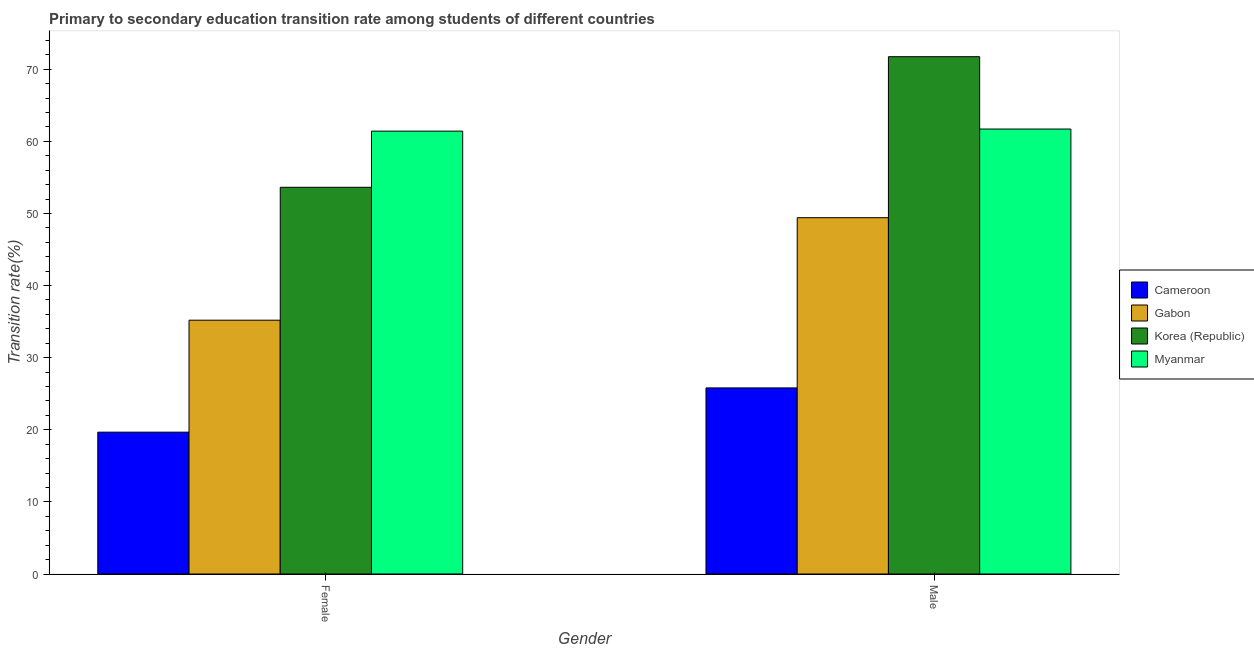How many different coloured bars are there?
Your answer should be very brief. 4. How many bars are there on the 2nd tick from the left?
Keep it short and to the point. 4. What is the label of the 2nd group of bars from the left?
Give a very brief answer. Male. What is the transition rate among male students in Korea (Republic)?
Give a very brief answer. 71.74. Across all countries, what is the maximum transition rate among male students?
Your answer should be very brief. 71.74. Across all countries, what is the minimum transition rate among female students?
Provide a succinct answer. 19.67. In which country was the transition rate among female students maximum?
Keep it short and to the point. Myanmar. In which country was the transition rate among male students minimum?
Make the answer very short. Cameroon. What is the total transition rate among female students in the graph?
Make the answer very short. 169.92. What is the difference between the transition rate among female students in Gabon and that in Myanmar?
Your response must be concise. -26.22. What is the difference between the transition rate among female students in Cameroon and the transition rate among male students in Myanmar?
Your answer should be very brief. -42.04. What is the average transition rate among female students per country?
Offer a terse response. 42.48. What is the difference between the transition rate among male students and transition rate among female students in Korea (Republic)?
Ensure brevity in your answer.  18.11. What is the ratio of the transition rate among female students in Myanmar to that in Cameroon?
Your answer should be compact. 3.12. What does the 2nd bar from the left in Male represents?
Provide a short and direct response. Gabon. What does the 3rd bar from the right in Male represents?
Make the answer very short. Gabon. Are all the bars in the graph horizontal?
Ensure brevity in your answer.  No. How many countries are there in the graph?
Your response must be concise. 4. What is the difference between two consecutive major ticks on the Y-axis?
Give a very brief answer. 10. Are the values on the major ticks of Y-axis written in scientific E-notation?
Make the answer very short. No. Does the graph contain any zero values?
Make the answer very short. No. Does the graph contain grids?
Offer a very short reply. No. How many legend labels are there?
Offer a very short reply. 4. How are the legend labels stacked?
Offer a very short reply. Vertical. What is the title of the graph?
Provide a short and direct response. Primary to secondary education transition rate among students of different countries. Does "Channel Islands" appear as one of the legend labels in the graph?
Your response must be concise. No. What is the label or title of the Y-axis?
Your answer should be compact. Transition rate(%). What is the Transition rate(%) in Cameroon in Female?
Keep it short and to the point. 19.67. What is the Transition rate(%) of Gabon in Female?
Give a very brief answer. 35.2. What is the Transition rate(%) of Korea (Republic) in Female?
Your answer should be very brief. 53.63. What is the Transition rate(%) in Myanmar in Female?
Offer a terse response. 61.42. What is the Transition rate(%) of Cameroon in Male?
Make the answer very short. 25.81. What is the Transition rate(%) of Gabon in Male?
Provide a short and direct response. 49.42. What is the Transition rate(%) of Korea (Republic) in Male?
Your response must be concise. 71.74. What is the Transition rate(%) of Myanmar in Male?
Provide a succinct answer. 61.71. Across all Gender, what is the maximum Transition rate(%) in Cameroon?
Offer a terse response. 25.81. Across all Gender, what is the maximum Transition rate(%) in Gabon?
Your response must be concise. 49.42. Across all Gender, what is the maximum Transition rate(%) of Korea (Republic)?
Ensure brevity in your answer.  71.74. Across all Gender, what is the maximum Transition rate(%) of Myanmar?
Your answer should be very brief. 61.71. Across all Gender, what is the minimum Transition rate(%) of Cameroon?
Make the answer very short. 19.67. Across all Gender, what is the minimum Transition rate(%) of Gabon?
Give a very brief answer. 35.2. Across all Gender, what is the minimum Transition rate(%) of Korea (Republic)?
Offer a terse response. 53.63. Across all Gender, what is the minimum Transition rate(%) in Myanmar?
Provide a succinct answer. 61.42. What is the total Transition rate(%) in Cameroon in the graph?
Offer a terse response. 45.48. What is the total Transition rate(%) of Gabon in the graph?
Offer a terse response. 84.61. What is the total Transition rate(%) in Korea (Republic) in the graph?
Your answer should be very brief. 125.37. What is the total Transition rate(%) of Myanmar in the graph?
Ensure brevity in your answer.  123.13. What is the difference between the Transition rate(%) of Cameroon in Female and that in Male?
Ensure brevity in your answer.  -6.14. What is the difference between the Transition rate(%) in Gabon in Female and that in Male?
Make the answer very short. -14.22. What is the difference between the Transition rate(%) in Korea (Republic) in Female and that in Male?
Your answer should be very brief. -18.11. What is the difference between the Transition rate(%) in Myanmar in Female and that in Male?
Your answer should be compact. -0.29. What is the difference between the Transition rate(%) in Cameroon in Female and the Transition rate(%) in Gabon in Male?
Offer a terse response. -29.74. What is the difference between the Transition rate(%) in Cameroon in Female and the Transition rate(%) in Korea (Republic) in Male?
Your response must be concise. -52.07. What is the difference between the Transition rate(%) in Cameroon in Female and the Transition rate(%) in Myanmar in Male?
Keep it short and to the point. -42.04. What is the difference between the Transition rate(%) in Gabon in Female and the Transition rate(%) in Korea (Republic) in Male?
Keep it short and to the point. -36.54. What is the difference between the Transition rate(%) in Gabon in Female and the Transition rate(%) in Myanmar in Male?
Your answer should be compact. -26.51. What is the difference between the Transition rate(%) in Korea (Republic) in Female and the Transition rate(%) in Myanmar in Male?
Provide a short and direct response. -8.08. What is the average Transition rate(%) of Cameroon per Gender?
Your answer should be compact. 22.74. What is the average Transition rate(%) of Gabon per Gender?
Offer a very short reply. 42.31. What is the average Transition rate(%) of Korea (Republic) per Gender?
Offer a very short reply. 62.69. What is the average Transition rate(%) in Myanmar per Gender?
Make the answer very short. 61.56. What is the difference between the Transition rate(%) of Cameroon and Transition rate(%) of Gabon in Female?
Provide a short and direct response. -15.53. What is the difference between the Transition rate(%) of Cameroon and Transition rate(%) of Korea (Republic) in Female?
Provide a succinct answer. -33.96. What is the difference between the Transition rate(%) in Cameroon and Transition rate(%) in Myanmar in Female?
Give a very brief answer. -41.75. What is the difference between the Transition rate(%) in Gabon and Transition rate(%) in Korea (Republic) in Female?
Your answer should be compact. -18.43. What is the difference between the Transition rate(%) in Gabon and Transition rate(%) in Myanmar in Female?
Give a very brief answer. -26.22. What is the difference between the Transition rate(%) in Korea (Republic) and Transition rate(%) in Myanmar in Female?
Give a very brief answer. -7.79. What is the difference between the Transition rate(%) in Cameroon and Transition rate(%) in Gabon in Male?
Make the answer very short. -23.61. What is the difference between the Transition rate(%) of Cameroon and Transition rate(%) of Korea (Republic) in Male?
Offer a very short reply. -45.94. What is the difference between the Transition rate(%) in Cameroon and Transition rate(%) in Myanmar in Male?
Your answer should be compact. -35.9. What is the difference between the Transition rate(%) of Gabon and Transition rate(%) of Korea (Republic) in Male?
Keep it short and to the point. -22.33. What is the difference between the Transition rate(%) in Gabon and Transition rate(%) in Myanmar in Male?
Offer a very short reply. -12.29. What is the difference between the Transition rate(%) in Korea (Republic) and Transition rate(%) in Myanmar in Male?
Offer a terse response. 10.03. What is the ratio of the Transition rate(%) in Cameroon in Female to that in Male?
Your answer should be very brief. 0.76. What is the ratio of the Transition rate(%) in Gabon in Female to that in Male?
Your response must be concise. 0.71. What is the ratio of the Transition rate(%) of Korea (Republic) in Female to that in Male?
Provide a short and direct response. 0.75. What is the ratio of the Transition rate(%) of Myanmar in Female to that in Male?
Your answer should be very brief. 1. What is the difference between the highest and the second highest Transition rate(%) of Cameroon?
Your answer should be compact. 6.14. What is the difference between the highest and the second highest Transition rate(%) in Gabon?
Offer a very short reply. 14.22. What is the difference between the highest and the second highest Transition rate(%) of Korea (Republic)?
Provide a succinct answer. 18.11. What is the difference between the highest and the second highest Transition rate(%) in Myanmar?
Ensure brevity in your answer.  0.29. What is the difference between the highest and the lowest Transition rate(%) in Cameroon?
Make the answer very short. 6.14. What is the difference between the highest and the lowest Transition rate(%) of Gabon?
Provide a succinct answer. 14.22. What is the difference between the highest and the lowest Transition rate(%) of Korea (Republic)?
Provide a succinct answer. 18.11. What is the difference between the highest and the lowest Transition rate(%) of Myanmar?
Your response must be concise. 0.29. 